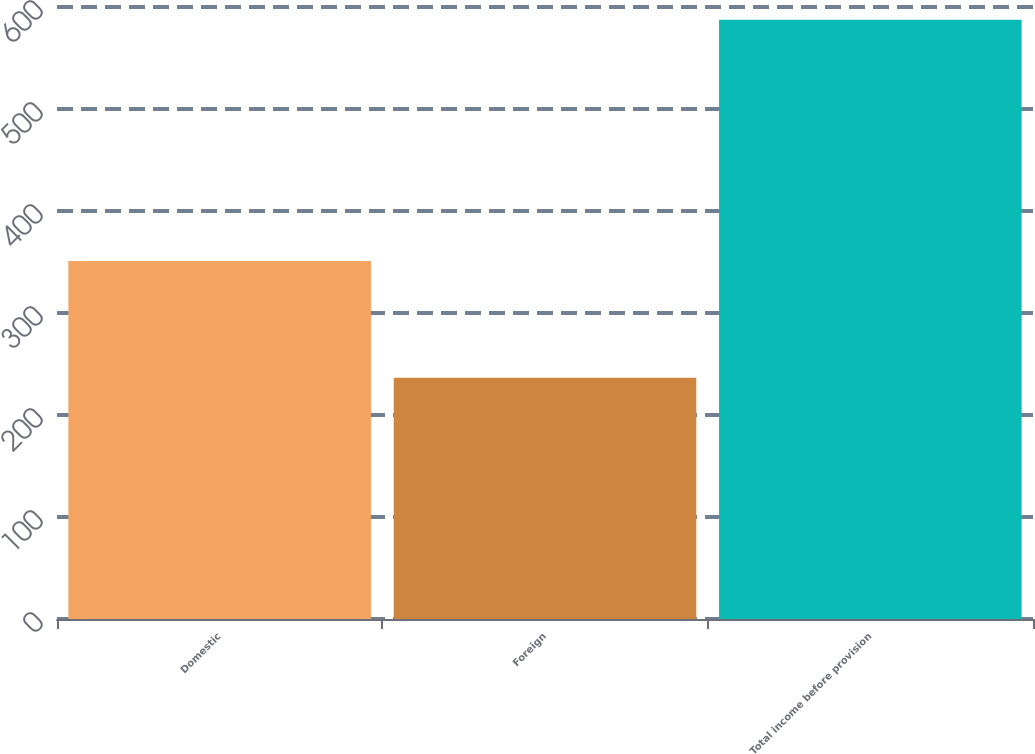<chart> <loc_0><loc_0><loc_500><loc_500><bar_chart><fcel>Domestic<fcel>Foreign<fcel>Total income before provision<nl><fcel>351.1<fcel>236.4<fcel>587.5<nl></chart> 